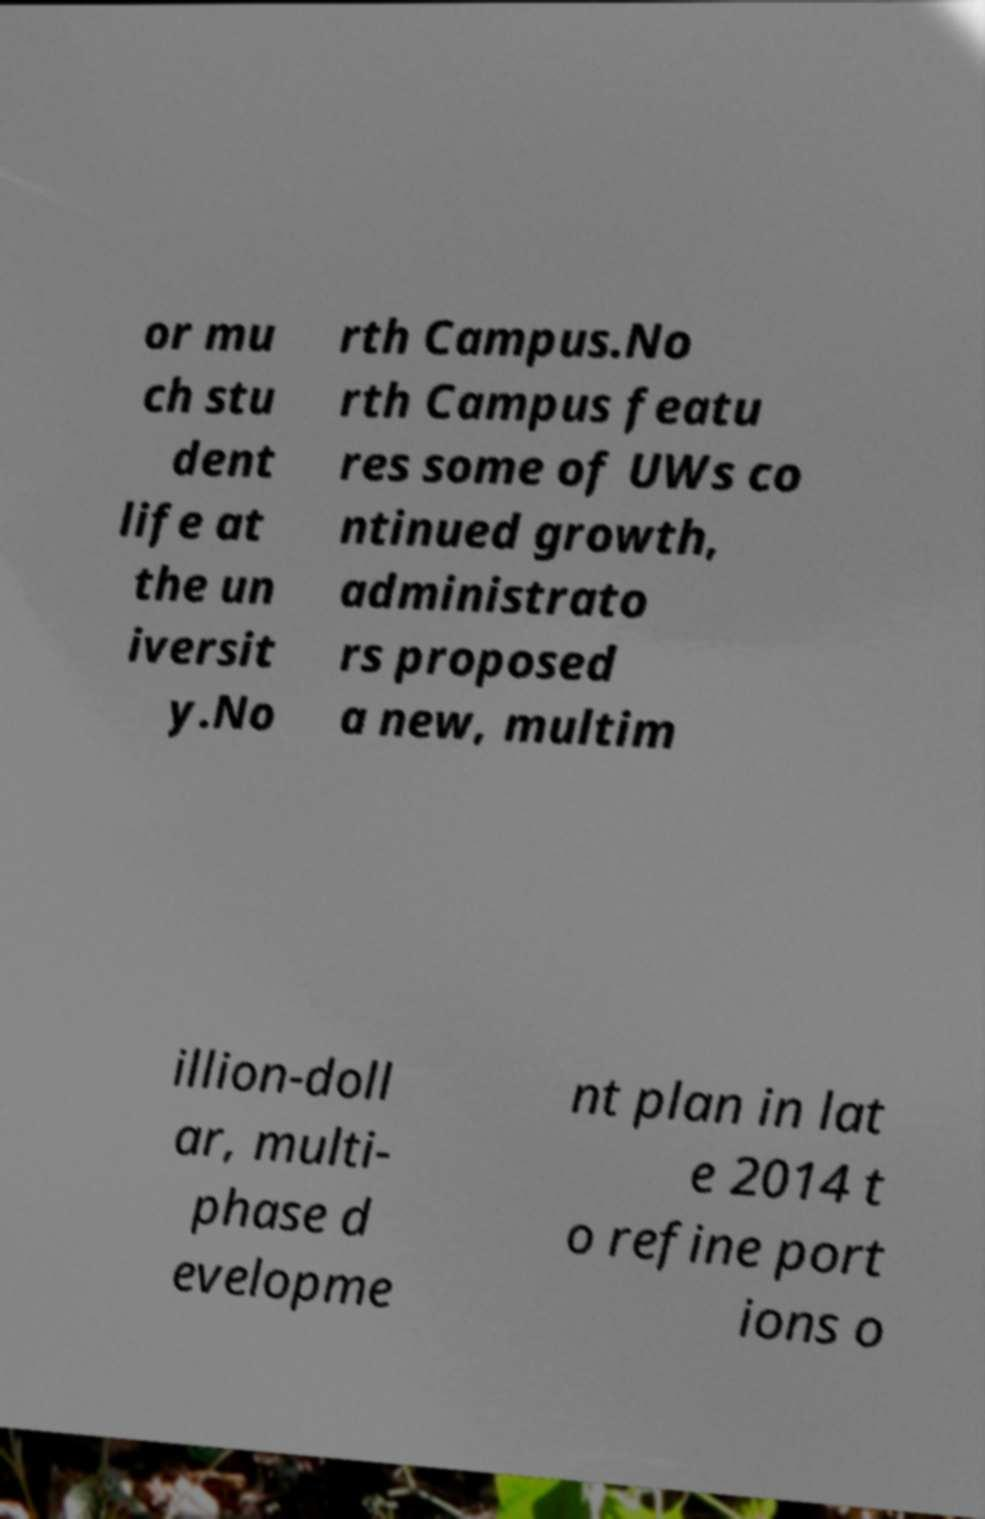There's text embedded in this image that I need extracted. Can you transcribe it verbatim? or mu ch stu dent life at the un iversit y.No rth Campus.No rth Campus featu res some of UWs co ntinued growth, administrato rs proposed a new, multim illion-doll ar, multi- phase d evelopme nt plan in lat e 2014 t o refine port ions o 